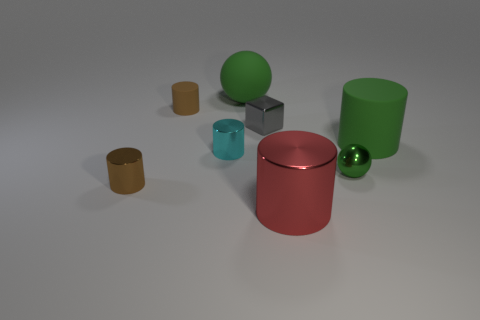There is a shiny ball that is the same color as the big matte cylinder; what is its size?
Ensure brevity in your answer.  Small. There is a tiny object that is on the right side of the gray shiny thing; is its color the same as the big rubber sphere?
Provide a succinct answer. Yes. What is the size of the brown metallic thing that is the same shape as the red thing?
Your answer should be compact. Small. Is there any other thing that has the same material as the small green ball?
Give a very brief answer. Yes. Is there a big green matte thing that is in front of the brown cylinder in front of the green matte object that is to the right of the big red metal thing?
Offer a terse response. No. There is a big green object that is to the right of the small cube; what is it made of?
Your answer should be very brief. Rubber. What number of tiny things are either cyan cylinders or purple metallic cylinders?
Make the answer very short. 1. Does the green sphere that is behind the shiny sphere have the same size as the small rubber thing?
Offer a very short reply. No. What number of other objects are the same color as the large metallic object?
Provide a short and direct response. 0. What material is the small cyan object?
Offer a terse response. Metal. 